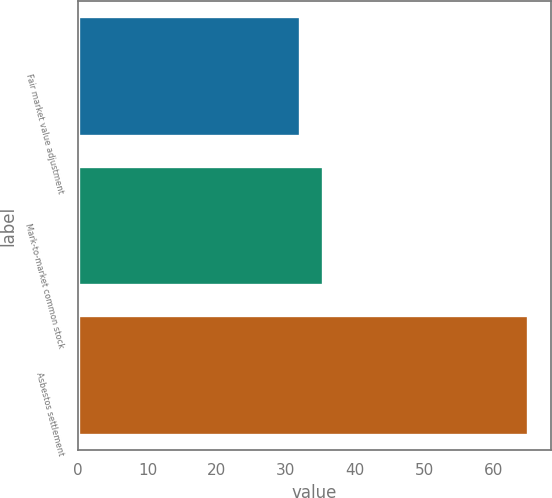Convert chart. <chart><loc_0><loc_0><loc_500><loc_500><bar_chart><fcel>Fair market value adjustment<fcel>Mark-to-market common stock<fcel>Asbestos settlement<nl><fcel>32<fcel>35.3<fcel>65<nl></chart> 